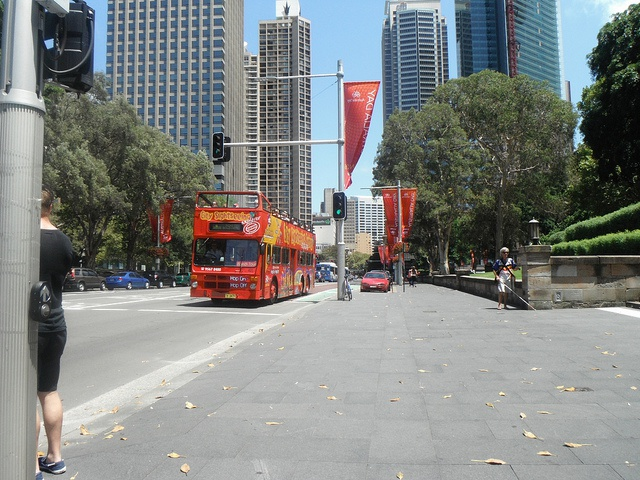Describe the objects in this image and their specific colors. I can see bus in darkgreen, black, brown, maroon, and gray tones, people in darkgreen, black, gray, darkgray, and lightgray tones, car in darkgreen, black, and gray tones, people in darkgreen, black, gray, lightgray, and darkgray tones, and car in darkgreen, navy, darkblue, gray, and blue tones in this image. 